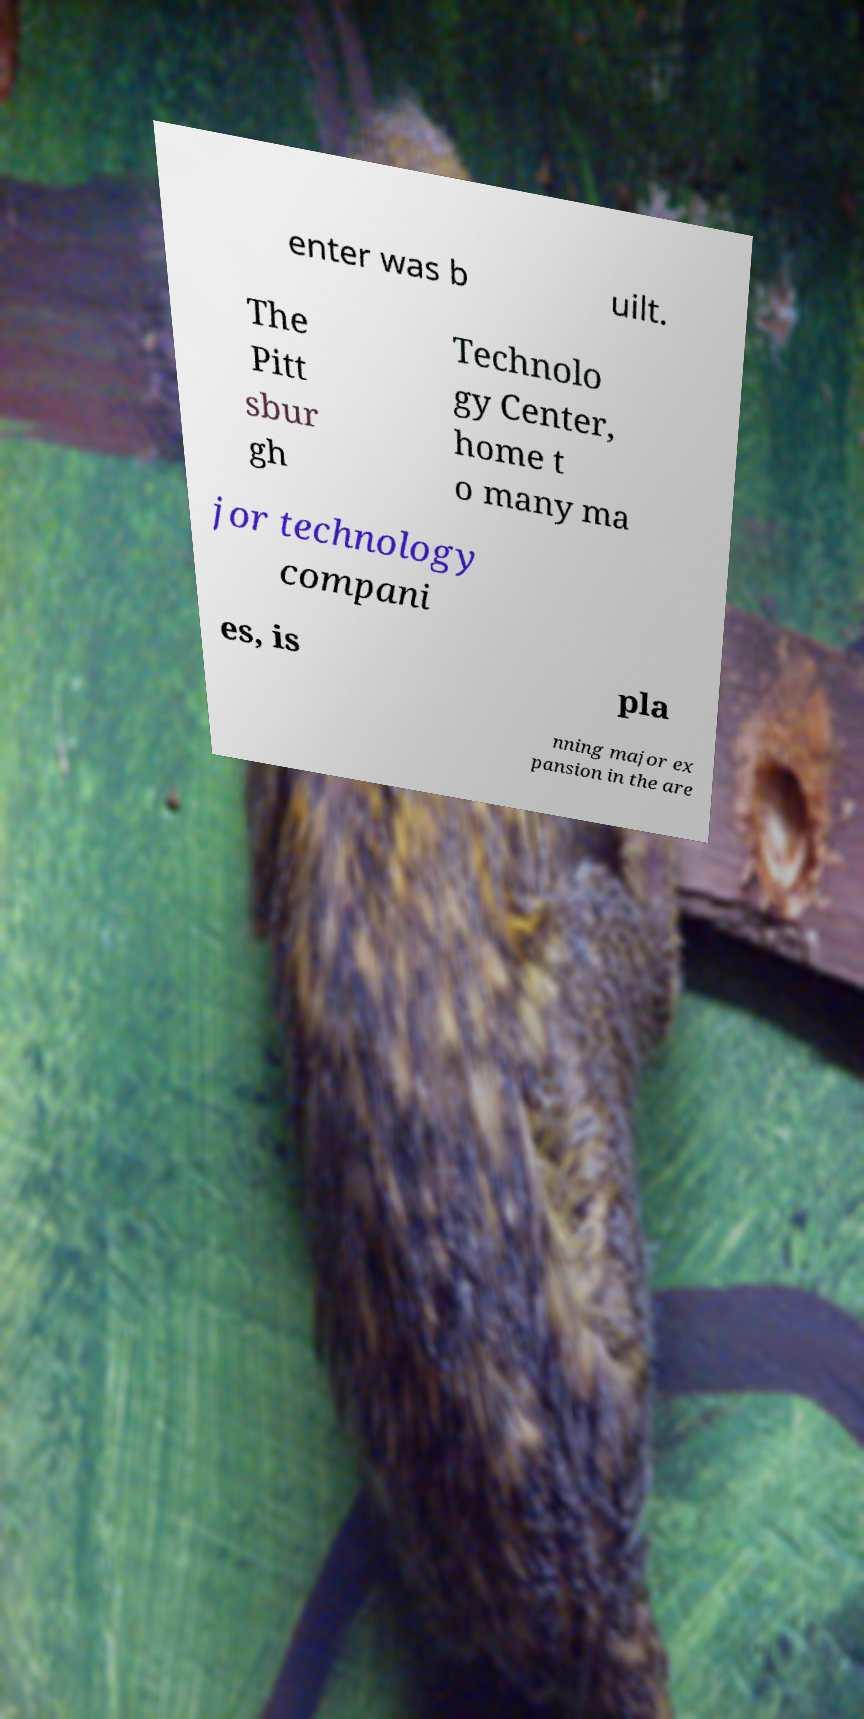Please identify and transcribe the text found in this image. enter was b uilt. The Pitt sbur gh Technolo gy Center, home t o many ma jor technology compani es, is pla nning major ex pansion in the are 